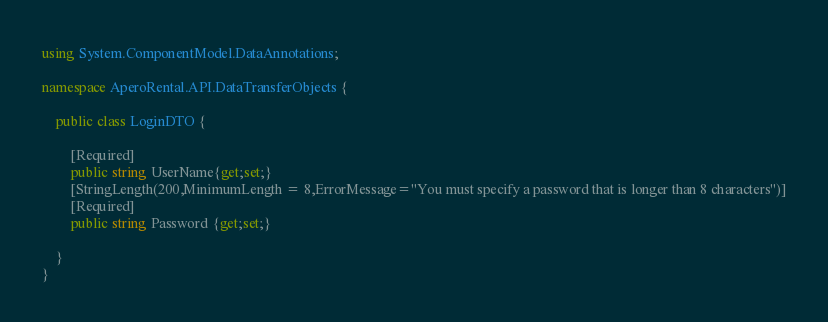Convert code to text. <code><loc_0><loc_0><loc_500><loc_500><_C#_>using System.ComponentModel.DataAnnotations;

namespace AperoRental.API.DataTransferObjects {

    public class LoginDTO {  
    
        [Required]
        public string UserName{get;set;}
        [StringLength(200,MinimumLength = 8,ErrorMessage="You must specify a password that is longer than 8 characters")]
        [Required]
        public string Password {get;set;}
        
    }
}</code> 